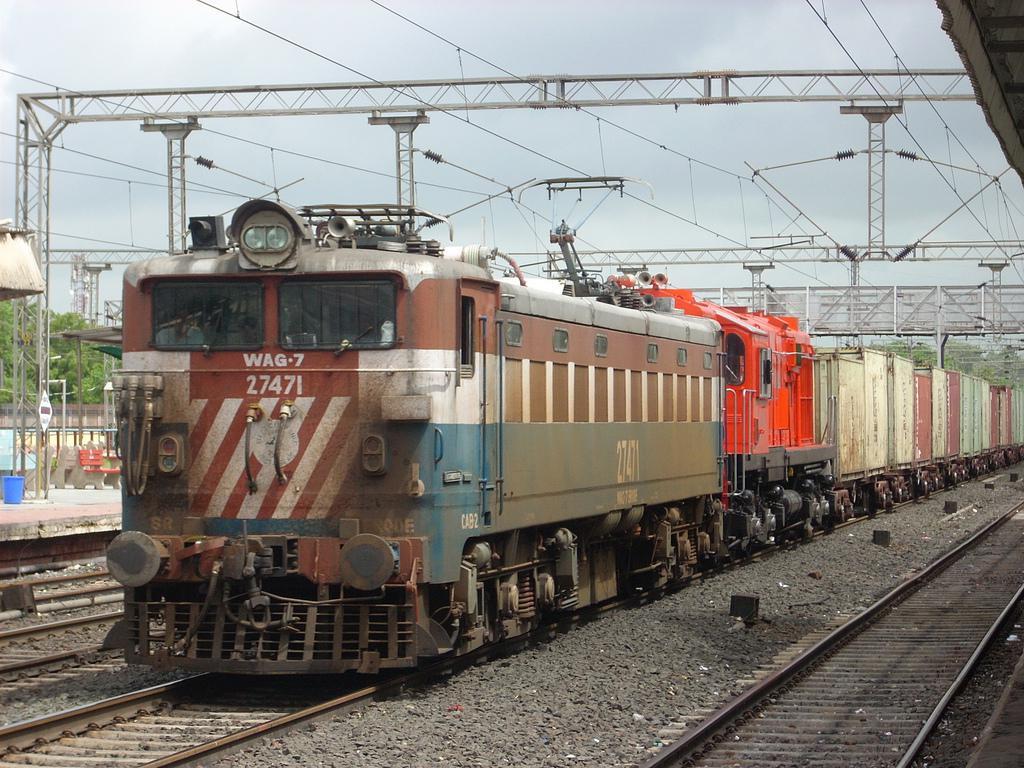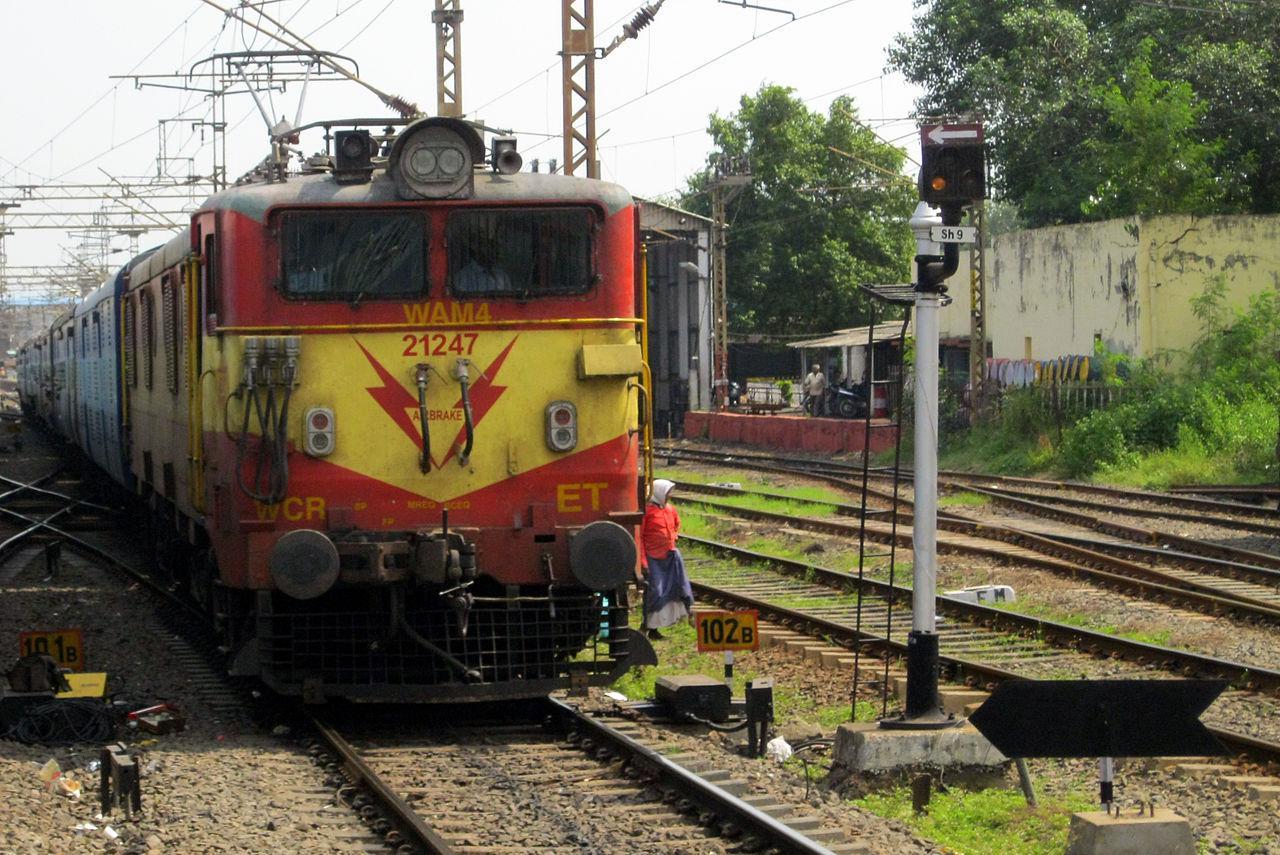The first image is the image on the left, the second image is the image on the right. For the images shown, is this caption "The red locomotive is pulling other train cars on the railroad tracks." true? Answer yes or no. Yes. 